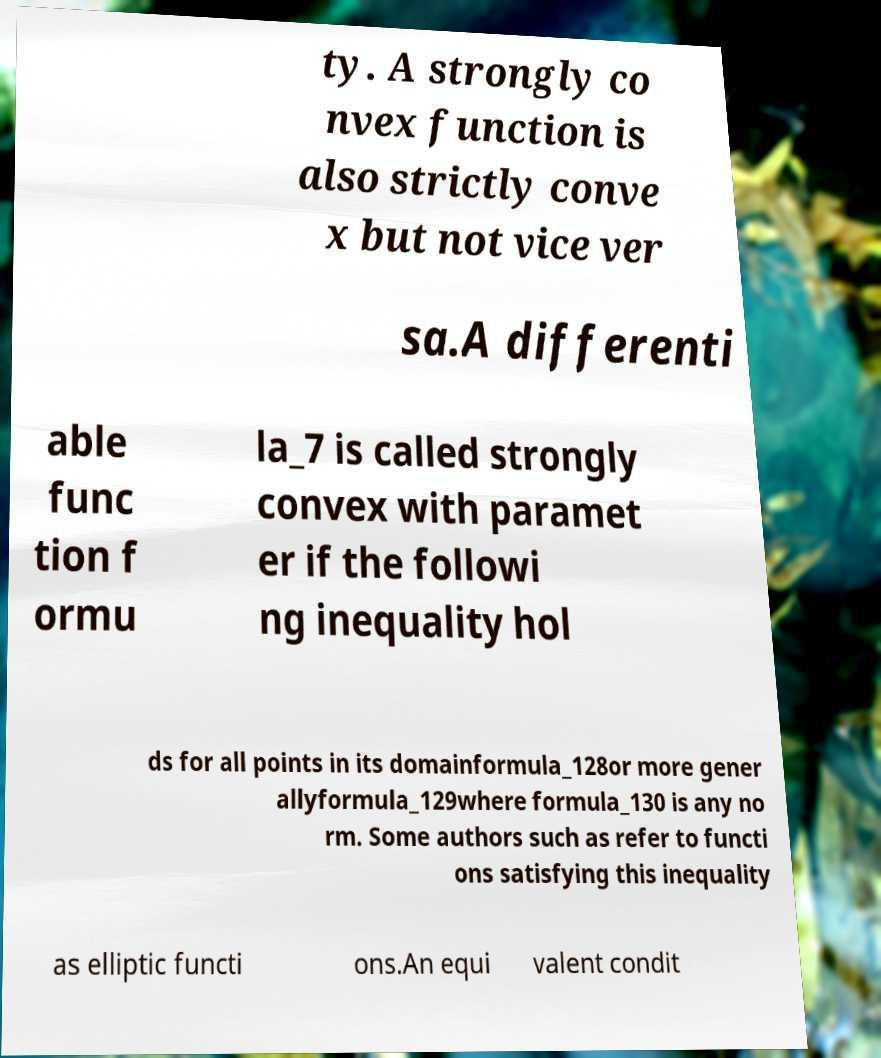What messages or text are displayed in this image? I need them in a readable, typed format. ty. A strongly co nvex function is also strictly conve x but not vice ver sa.A differenti able func tion f ormu la_7 is called strongly convex with paramet er if the followi ng inequality hol ds for all points in its domainformula_128or more gener allyformula_129where formula_130 is any no rm. Some authors such as refer to functi ons satisfying this inequality as elliptic functi ons.An equi valent condit 